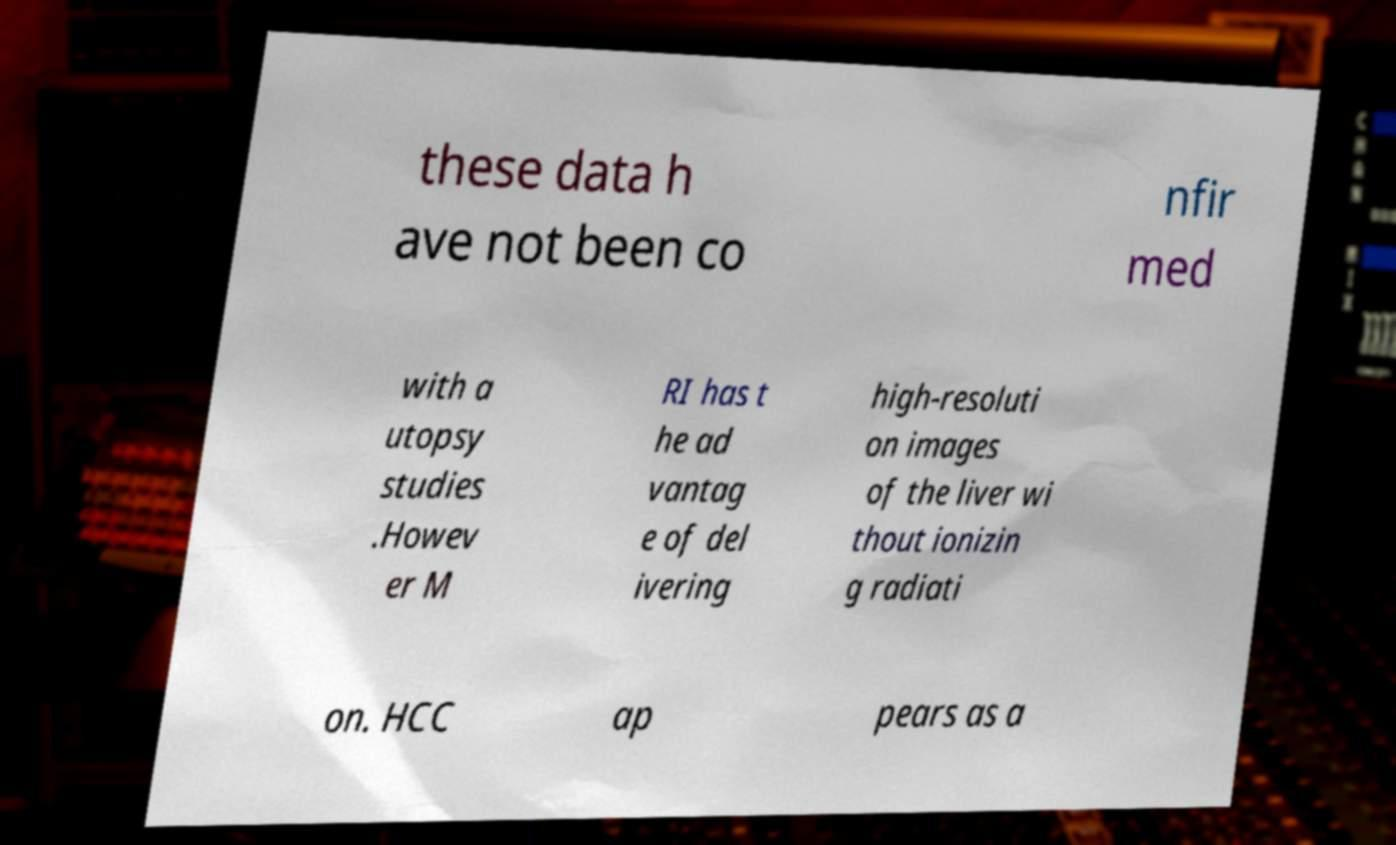For documentation purposes, I need the text within this image transcribed. Could you provide that? these data h ave not been co nfir med with a utopsy studies .Howev er M RI has t he ad vantag e of del ivering high-resoluti on images of the liver wi thout ionizin g radiati on. HCC ap pears as a 